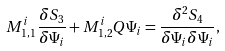<formula> <loc_0><loc_0><loc_500><loc_500>M ^ { i } _ { 1 , 1 } \frac { \delta S _ { 3 } } { \delta \Psi _ { i } } + M ^ { i } _ { 1 , 2 } Q \Psi _ { i } = \frac { \delta ^ { 2 } S _ { 4 } } { \delta \Psi _ { i } \delta \Psi _ { i } } ,</formula> 